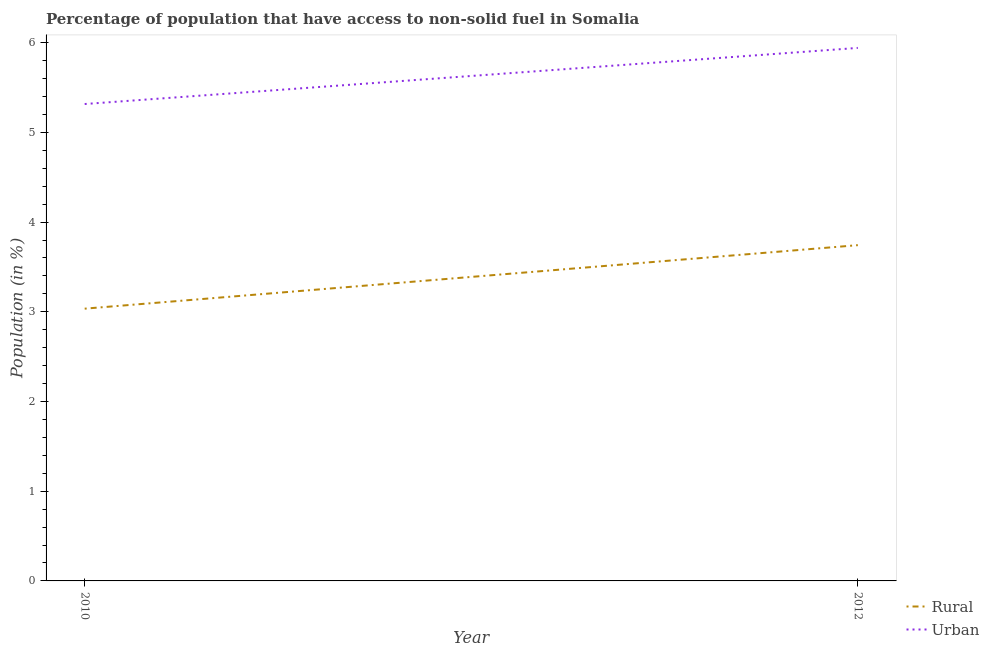How many different coloured lines are there?
Offer a very short reply. 2. Does the line corresponding to urban population intersect with the line corresponding to rural population?
Offer a terse response. No. What is the urban population in 2012?
Provide a succinct answer. 5.94. Across all years, what is the maximum rural population?
Offer a terse response. 3.74. Across all years, what is the minimum urban population?
Offer a very short reply. 5.32. In which year was the rural population minimum?
Offer a very short reply. 2010. What is the total urban population in the graph?
Provide a succinct answer. 11.26. What is the difference between the urban population in 2010 and that in 2012?
Keep it short and to the point. -0.63. What is the difference between the rural population in 2012 and the urban population in 2010?
Keep it short and to the point. -1.57. What is the average rural population per year?
Offer a terse response. 3.39. In the year 2010, what is the difference between the urban population and rural population?
Provide a succinct answer. 2.28. What is the ratio of the urban population in 2010 to that in 2012?
Provide a succinct answer. 0.89. Is the rural population strictly greater than the urban population over the years?
Your answer should be compact. No. How many lines are there?
Provide a short and direct response. 2. What is the difference between two consecutive major ticks on the Y-axis?
Make the answer very short. 1. Where does the legend appear in the graph?
Ensure brevity in your answer.  Bottom right. How many legend labels are there?
Offer a very short reply. 2. What is the title of the graph?
Provide a short and direct response. Percentage of population that have access to non-solid fuel in Somalia. Does "Study and work" appear as one of the legend labels in the graph?
Your answer should be very brief. No. What is the label or title of the X-axis?
Give a very brief answer. Year. What is the label or title of the Y-axis?
Keep it short and to the point. Population (in %). What is the Population (in %) of Rural in 2010?
Provide a succinct answer. 3.03. What is the Population (in %) of Urban in 2010?
Keep it short and to the point. 5.32. What is the Population (in %) in Rural in 2012?
Your answer should be compact. 3.74. What is the Population (in %) of Urban in 2012?
Provide a short and direct response. 5.94. Across all years, what is the maximum Population (in %) of Rural?
Provide a short and direct response. 3.74. Across all years, what is the maximum Population (in %) of Urban?
Offer a very short reply. 5.94. Across all years, what is the minimum Population (in %) of Rural?
Make the answer very short. 3.03. Across all years, what is the minimum Population (in %) in Urban?
Your answer should be very brief. 5.32. What is the total Population (in %) of Rural in the graph?
Provide a succinct answer. 6.78. What is the total Population (in %) of Urban in the graph?
Make the answer very short. 11.26. What is the difference between the Population (in %) of Rural in 2010 and that in 2012?
Your response must be concise. -0.71. What is the difference between the Population (in %) of Urban in 2010 and that in 2012?
Keep it short and to the point. -0.63. What is the difference between the Population (in %) of Rural in 2010 and the Population (in %) of Urban in 2012?
Your response must be concise. -2.91. What is the average Population (in %) in Rural per year?
Make the answer very short. 3.39. What is the average Population (in %) in Urban per year?
Your answer should be very brief. 5.63. In the year 2010, what is the difference between the Population (in %) of Rural and Population (in %) of Urban?
Provide a succinct answer. -2.28. In the year 2012, what is the difference between the Population (in %) of Rural and Population (in %) of Urban?
Offer a terse response. -2.2. What is the ratio of the Population (in %) in Rural in 2010 to that in 2012?
Provide a succinct answer. 0.81. What is the ratio of the Population (in %) of Urban in 2010 to that in 2012?
Ensure brevity in your answer.  0.89. What is the difference between the highest and the second highest Population (in %) of Rural?
Ensure brevity in your answer.  0.71. What is the difference between the highest and the second highest Population (in %) in Urban?
Provide a succinct answer. 0.63. What is the difference between the highest and the lowest Population (in %) of Rural?
Offer a terse response. 0.71. What is the difference between the highest and the lowest Population (in %) in Urban?
Ensure brevity in your answer.  0.63. 